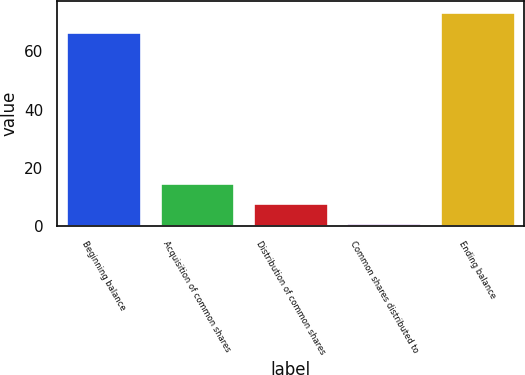Convert chart. <chart><loc_0><loc_0><loc_500><loc_500><bar_chart><fcel>Beginning balance<fcel>Acquisition of common shares<fcel>Distribution of common shares<fcel>Common shares distributed to<fcel>Ending balance<nl><fcel>66.8<fcel>14.6<fcel>7.75<fcel>0.9<fcel>73.65<nl></chart> 